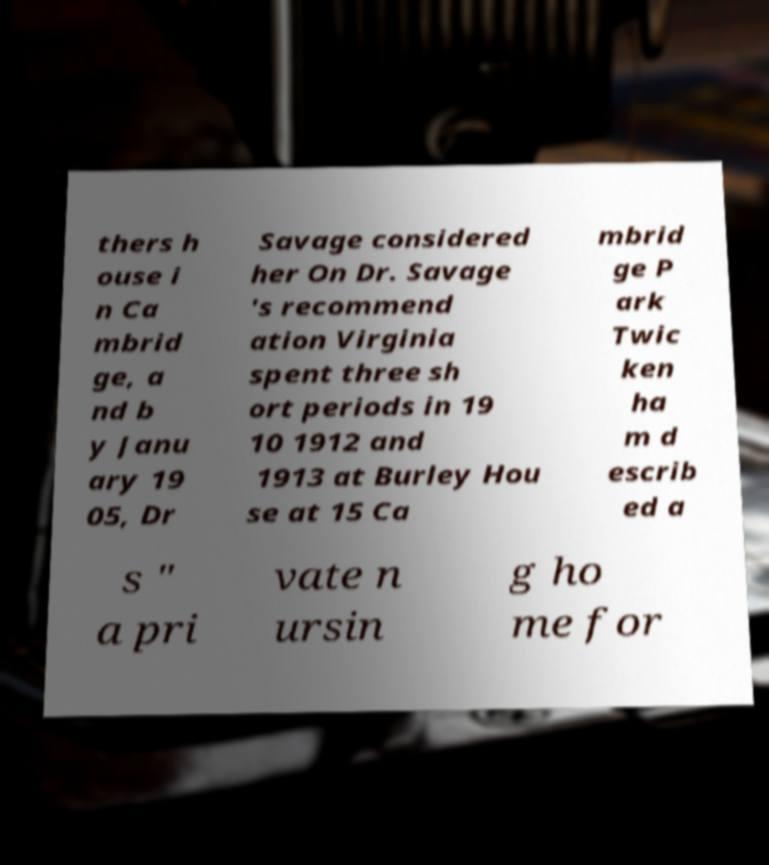I need the written content from this picture converted into text. Can you do that? thers h ouse i n Ca mbrid ge, a nd b y Janu ary 19 05, Dr Savage considered her On Dr. Savage 's recommend ation Virginia spent three sh ort periods in 19 10 1912 and 1913 at Burley Hou se at 15 Ca mbrid ge P ark Twic ken ha m d escrib ed a s " a pri vate n ursin g ho me for 